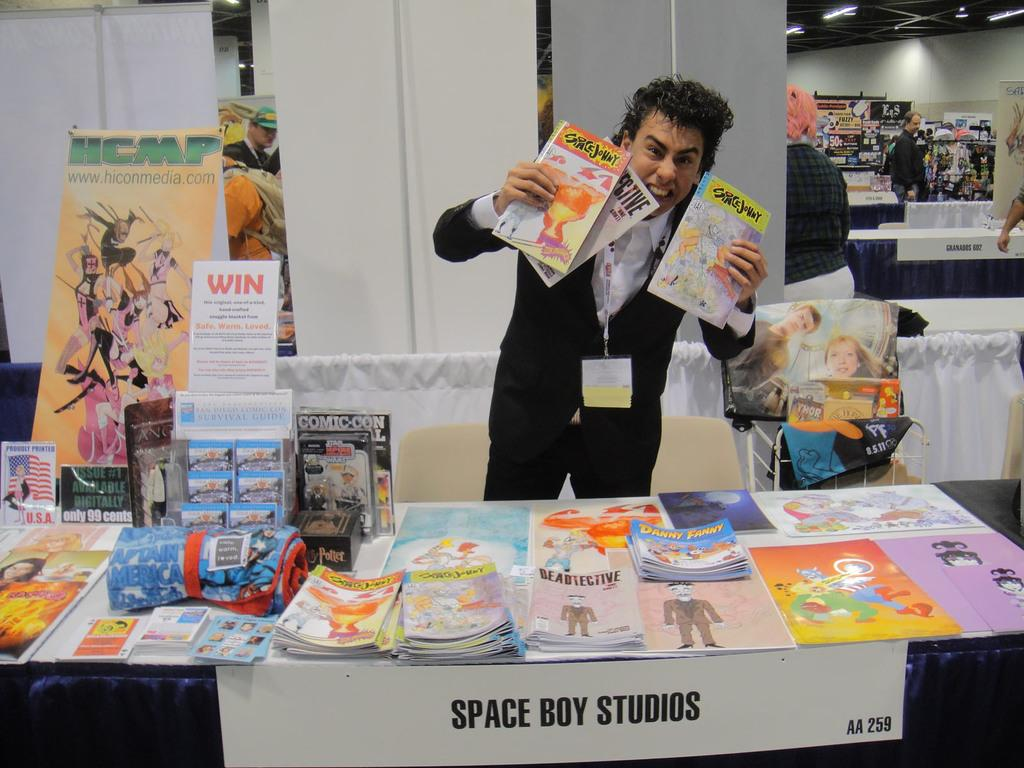<image>
Give a short and clear explanation of the subsequent image. a man holding some magazines for space boy studios 